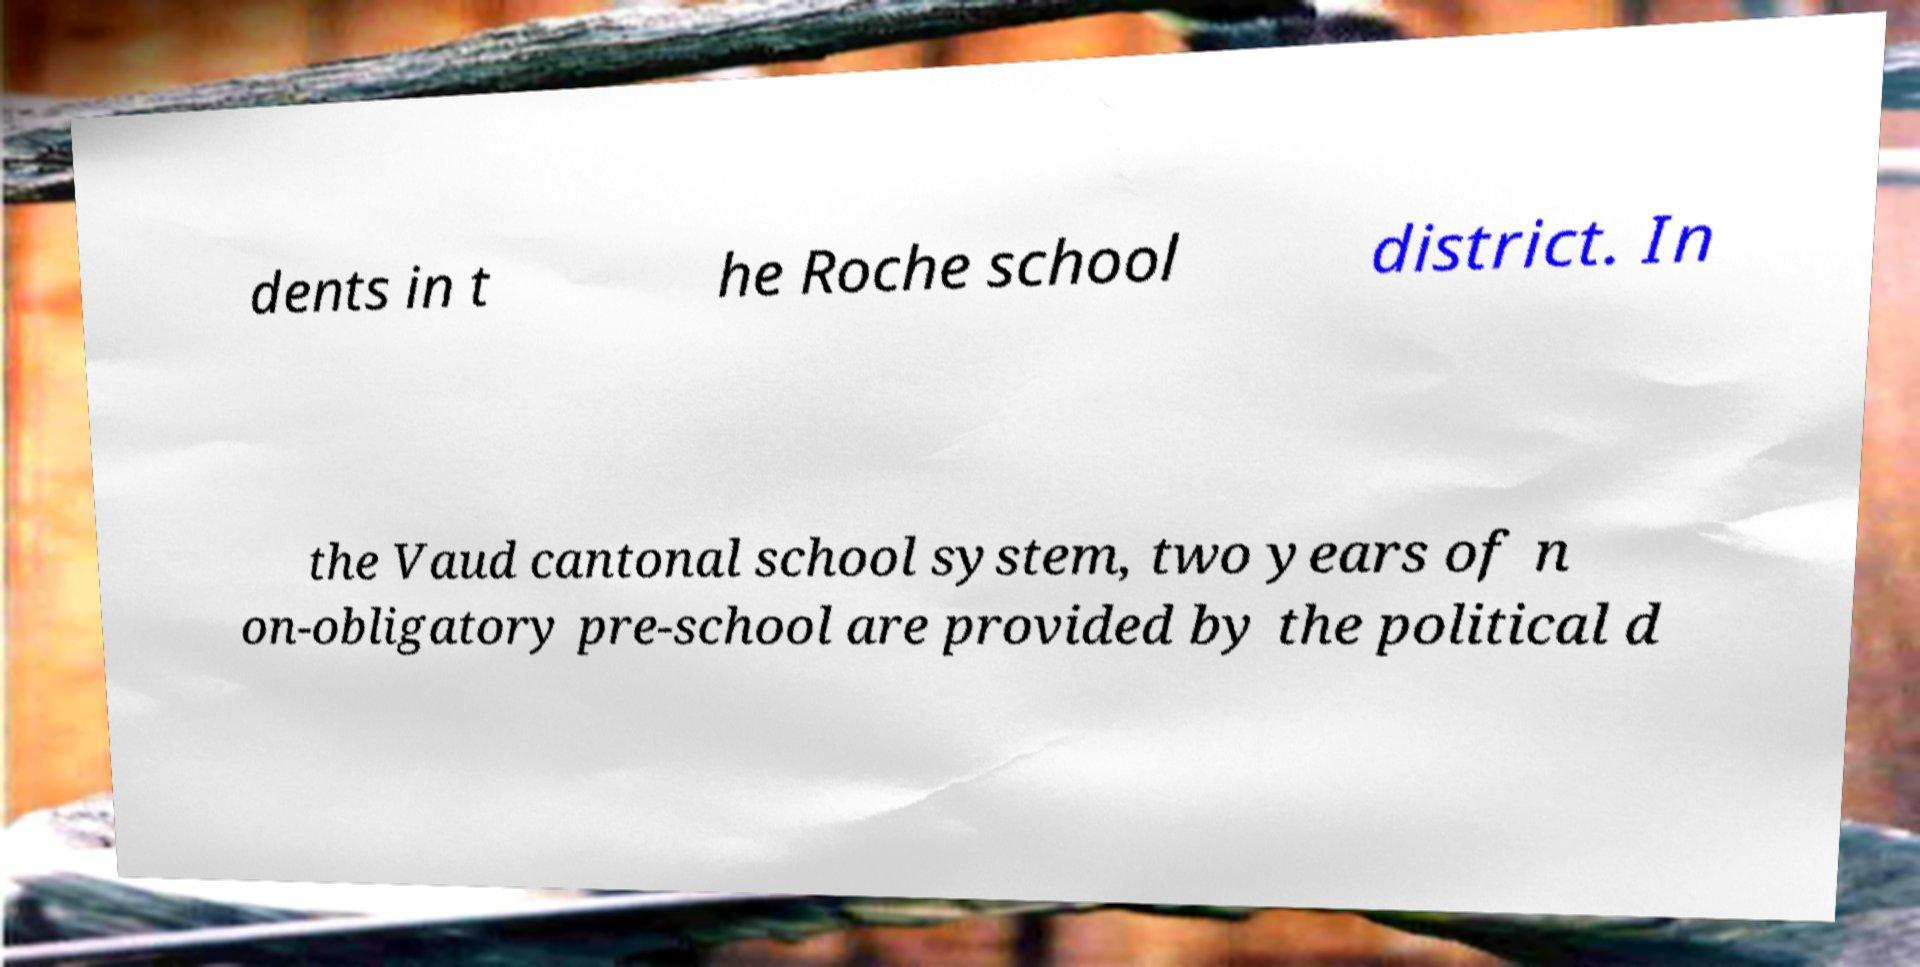What messages or text are displayed in this image? I need them in a readable, typed format. dents in t he Roche school district. In the Vaud cantonal school system, two years of n on-obligatory pre-school are provided by the political d 